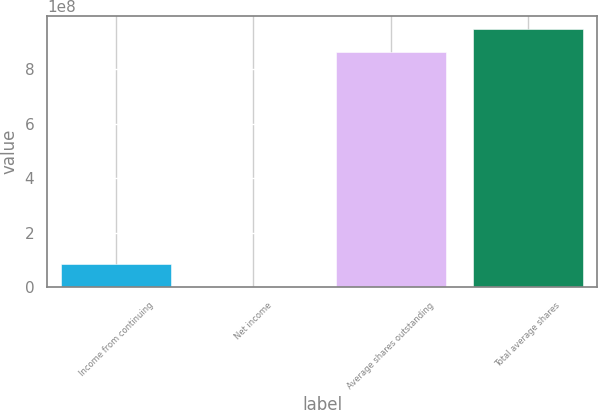Convert chart to OTSL. <chart><loc_0><loc_0><loc_500><loc_500><bar_chart><fcel>Income from continuing<fcel>Net income<fcel>Average shares outstanding<fcel>Total average shares<nl><fcel>8.62107e+07<fcel>1324<fcel>8.60671e+08<fcel>9.46881e+08<nl></chart> 